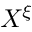Convert formula to latex. <formula><loc_0><loc_0><loc_500><loc_500>X ^ { \xi }</formula> 